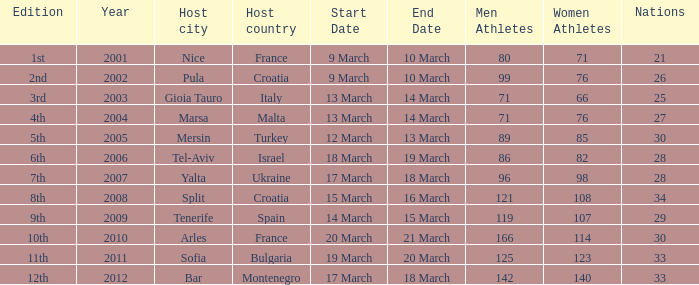In what year was Montenegro the host country? 2012.0. 